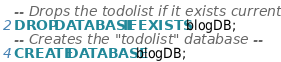<code> <loc_0><loc_0><loc_500><loc_500><_SQL_>-- Drops the todolist if it exists currently --
DROP DATABASE IF EXISTS blogDB;
-- Creates the "todolist" database --
CREATE DATABASE blogDB;</code> 